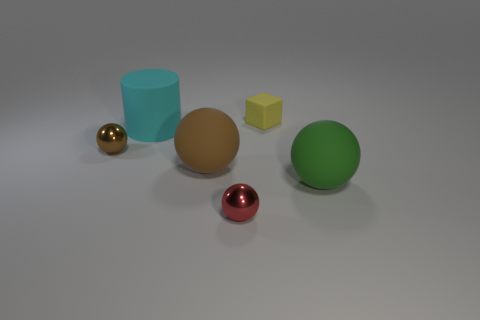What number of cylinders are big green matte objects or matte things?
Keep it short and to the point. 1. How big is the red shiny thing that is in front of the shiny thing behind the large matte thing that is to the right of the small yellow cube?
Your answer should be compact. Small. There is a small object that is both in front of the large cyan cylinder and right of the tiny brown thing; what color is it?
Your response must be concise. Red. There is a red metallic object; is it the same size as the matte thing that is behind the large matte cylinder?
Give a very brief answer. Yes. Is there anything else that is the same shape as the large green thing?
Offer a very short reply. Yes. The other big thing that is the same shape as the large green thing is what color?
Keep it short and to the point. Brown. Is the size of the brown shiny sphere the same as the red thing?
Your response must be concise. Yes. How many other things are the same size as the yellow matte thing?
Your answer should be compact. 2. How many objects are either large matte objects that are in front of the cyan matte cylinder or metal balls behind the large green matte object?
Make the answer very short. 3. What shape is the cyan object that is the same size as the brown rubber object?
Give a very brief answer. Cylinder. 